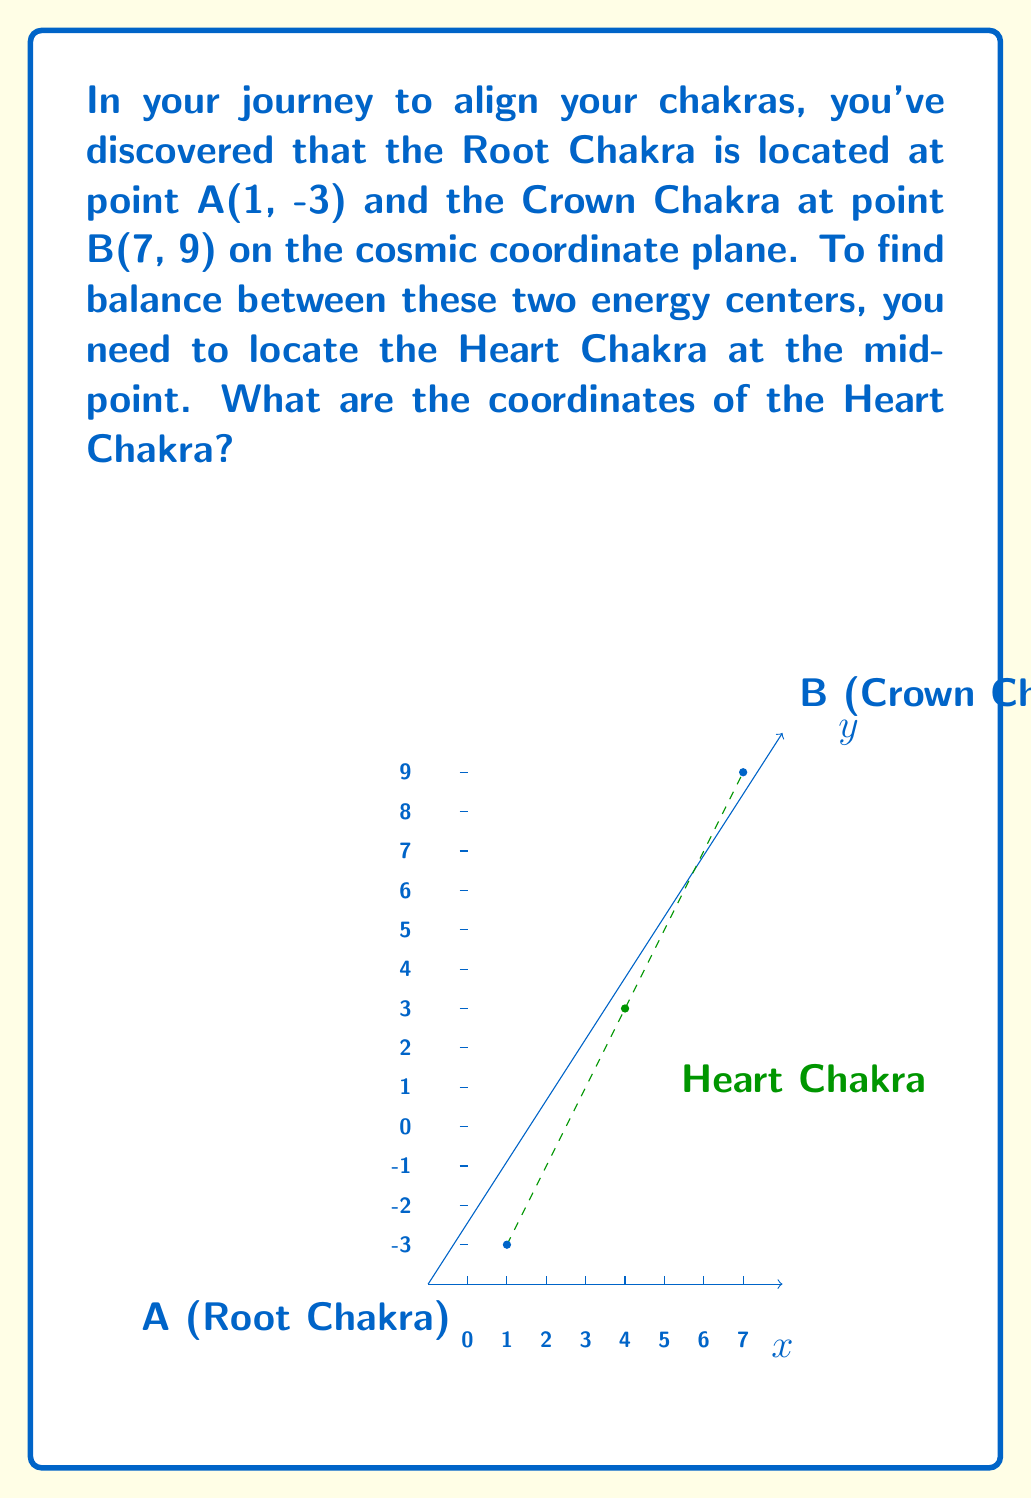What is the answer to this math problem? To find the midpoint between two points, we use the midpoint formula:

$$ \text{Midpoint} = \left(\frac{x_1 + x_2}{2}, \frac{y_1 + y_2}{2}\right) $$

Where $(x_1, y_1)$ are the coordinates of the first point and $(x_2, y_2)$ are the coordinates of the second point.

Given:
- Root Chakra (Point A): $(1, -3)$
- Crown Chakra (Point B): $(7, 9)$

Let's calculate the x-coordinate of the midpoint:
$$ x = \frac{x_1 + x_2}{2} = \frac{1 + 7}{2} = \frac{8}{2} = 4 $$

Now, let's calculate the y-coordinate of the midpoint:
$$ y = \frac{y_1 + y_2}{2} = \frac{-3 + 9}{2} = \frac{6}{2} = 3 $$

Therefore, the coordinates of the Heart Chakra (midpoint) are $(4, 3)$.
Answer: $(4, 3)$ 